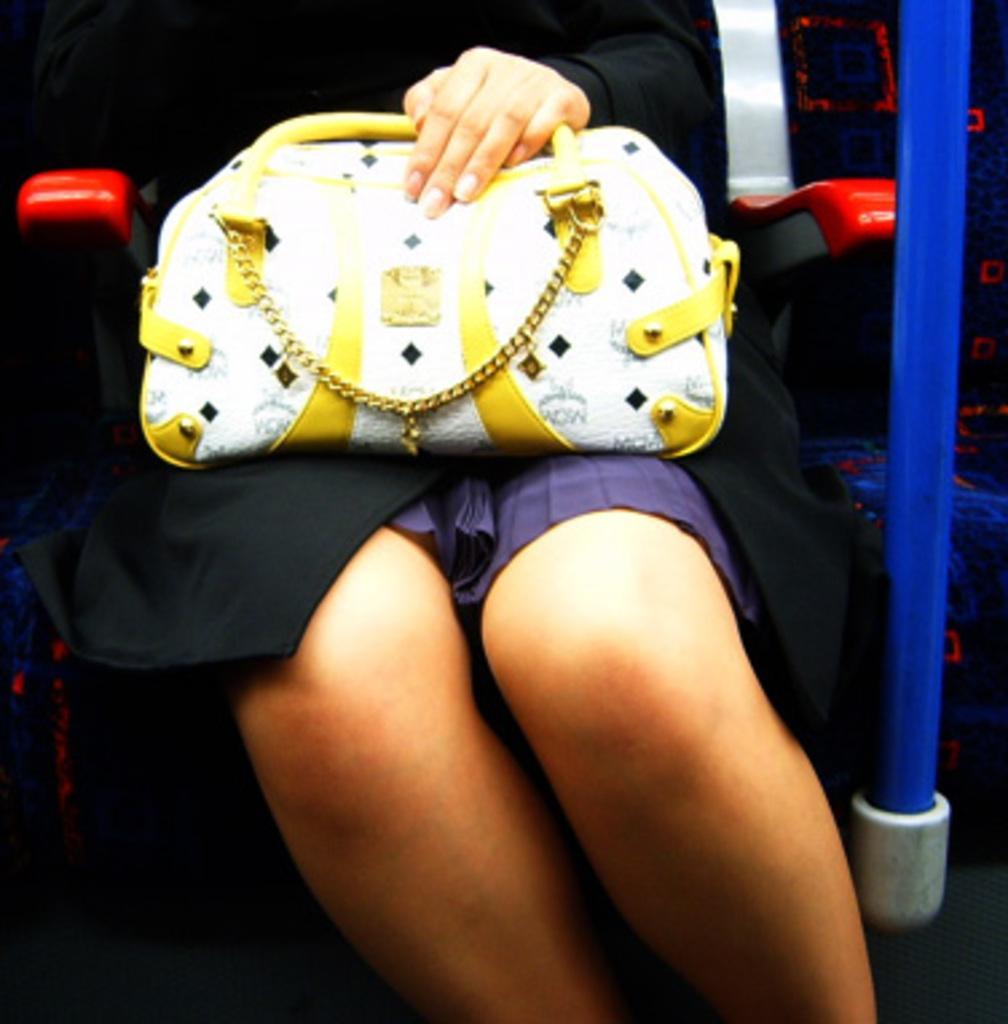In one or two sentences, can you explain what this image depicts? In this image, a woman is sitting on the chair and holding a white and yellow color bag in her hand, who's half visible. And a blue color pole is visible. I think, this image is taken inside a house. 